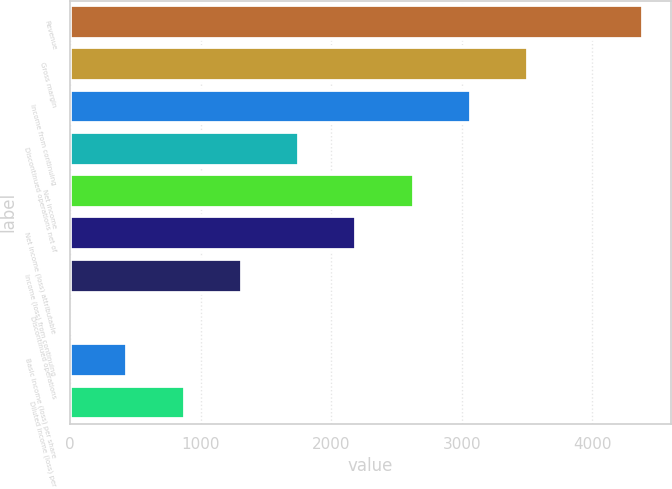<chart> <loc_0><loc_0><loc_500><loc_500><bar_chart><fcel>Revenue<fcel>Gross margin<fcel>Income from continuing<fcel>Discontinued operations net of<fcel>Net income<fcel>Net income (loss) attributable<fcel>Income (loss) from continuing<fcel>Discontinued operations<fcel>Basic income (loss) per share<fcel>Diluted income (loss) per<nl><fcel>4386<fcel>3508.82<fcel>3070.22<fcel>1754.42<fcel>2631.62<fcel>2193.02<fcel>1315.82<fcel>0.02<fcel>438.62<fcel>877.22<nl></chart> 